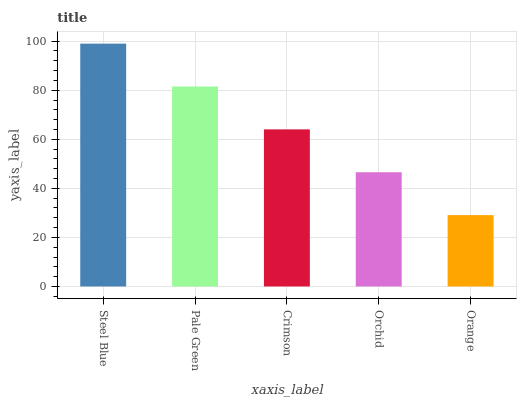Is Orange the minimum?
Answer yes or no. Yes. Is Steel Blue the maximum?
Answer yes or no. Yes. Is Pale Green the minimum?
Answer yes or no. No. Is Pale Green the maximum?
Answer yes or no. No. Is Steel Blue greater than Pale Green?
Answer yes or no. Yes. Is Pale Green less than Steel Blue?
Answer yes or no. Yes. Is Pale Green greater than Steel Blue?
Answer yes or no. No. Is Steel Blue less than Pale Green?
Answer yes or no. No. Is Crimson the high median?
Answer yes or no. Yes. Is Crimson the low median?
Answer yes or no. Yes. Is Orchid the high median?
Answer yes or no. No. Is Steel Blue the low median?
Answer yes or no. No. 